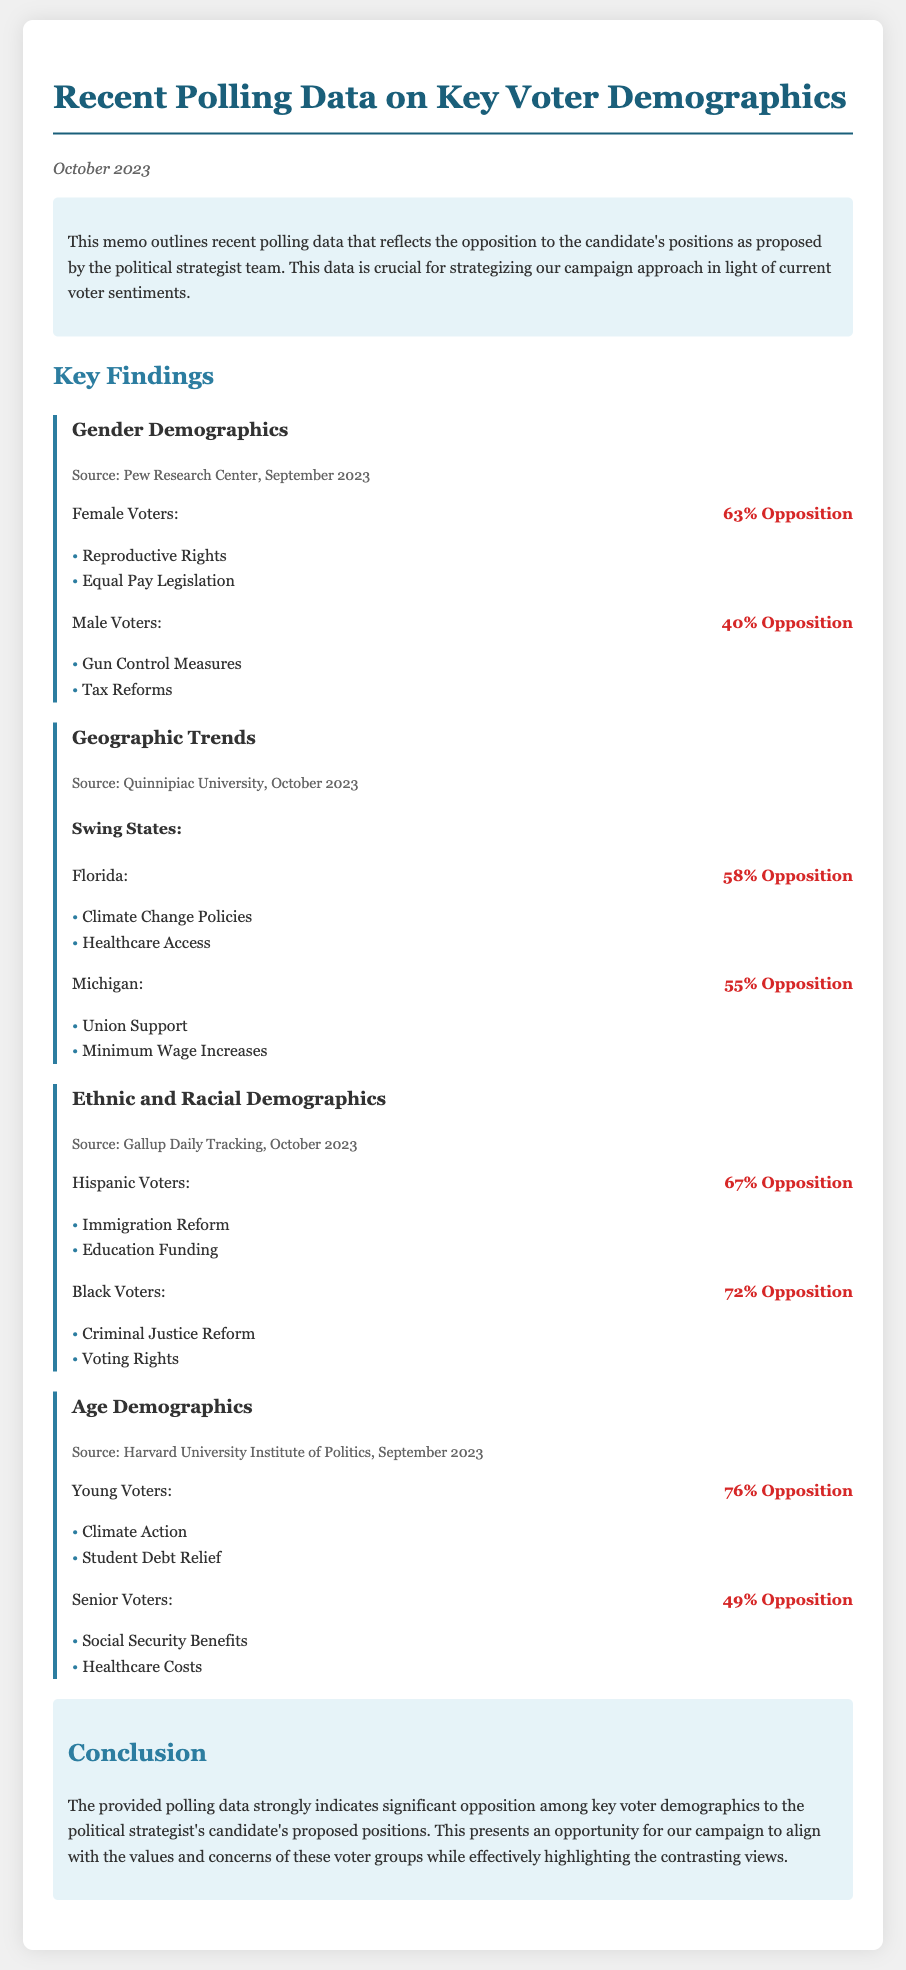What is the date of the memo? The date of the memo is mentioned in the header section, indicating when the document was written.
Answer: October 2023 What percentage of female voters oppose the candidate's positions? The document provides specific percentages related to voter opposition, particularly for female voters.
Answer: 63% Opposition Which voter demographic shows the highest opposition percentage? By analyzing the data presented, the demographic with the highest opposition percentage is identified.
Answer: Young Voters What is the opposition percentage for Black voters? The document specifically lists the percentage of opposition among Black voters regarding certain positions.
Answer: 72% Opposition Which state has an opposition percentage of 58%? The geographic trends section indicates voter opposition percentages by state, and one specific state is noted.
Answer: Florida What issue do 67% of Hispanic voters oppose? The document details the specific issues that different demographics oppose, particularly for Hispanic voters.
Answer: Immigration Reform How does the opposition among senior voters compare to young voters? A comparison of opposition percentages in differing age demographics is made in the document.
Answer: Lower What source is cited for the Gender Demographics finding? The memo references a specific research source for the findings related to voter demographics.
Answer: Pew Research Center What is the main concern among young voters as per the polling data? The document lists specific issues young voters are concerned about, indicating what drives their opposition.
Answer: Climate Action 